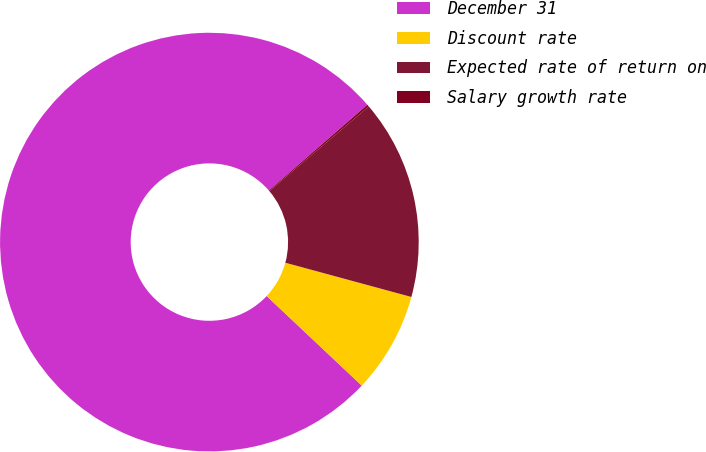Convert chart to OTSL. <chart><loc_0><loc_0><loc_500><loc_500><pie_chart><fcel>December 31<fcel>Discount rate<fcel>Expected rate of return on<fcel>Salary growth rate<nl><fcel>76.59%<fcel>7.8%<fcel>15.45%<fcel>0.16%<nl></chart> 